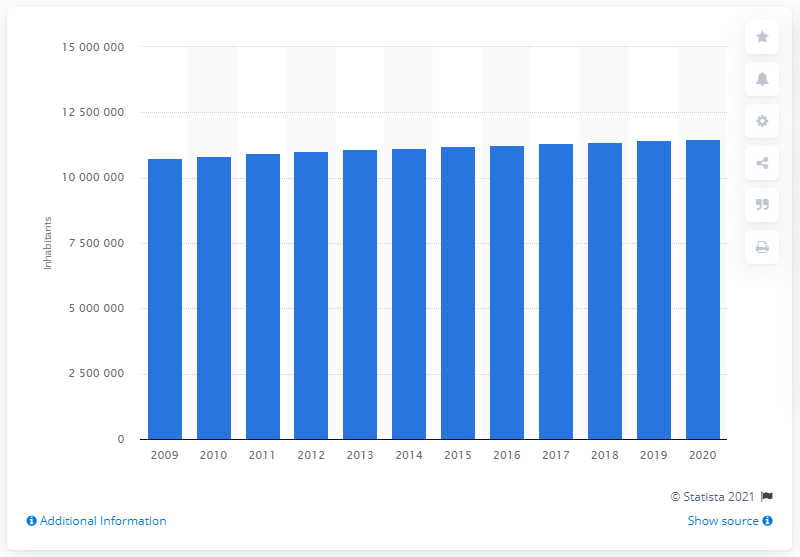Identify some key points in this picture. In 2020, the population of Belgium was 11,492,641. In 2009, the population of Belgium was 10,839,905. 